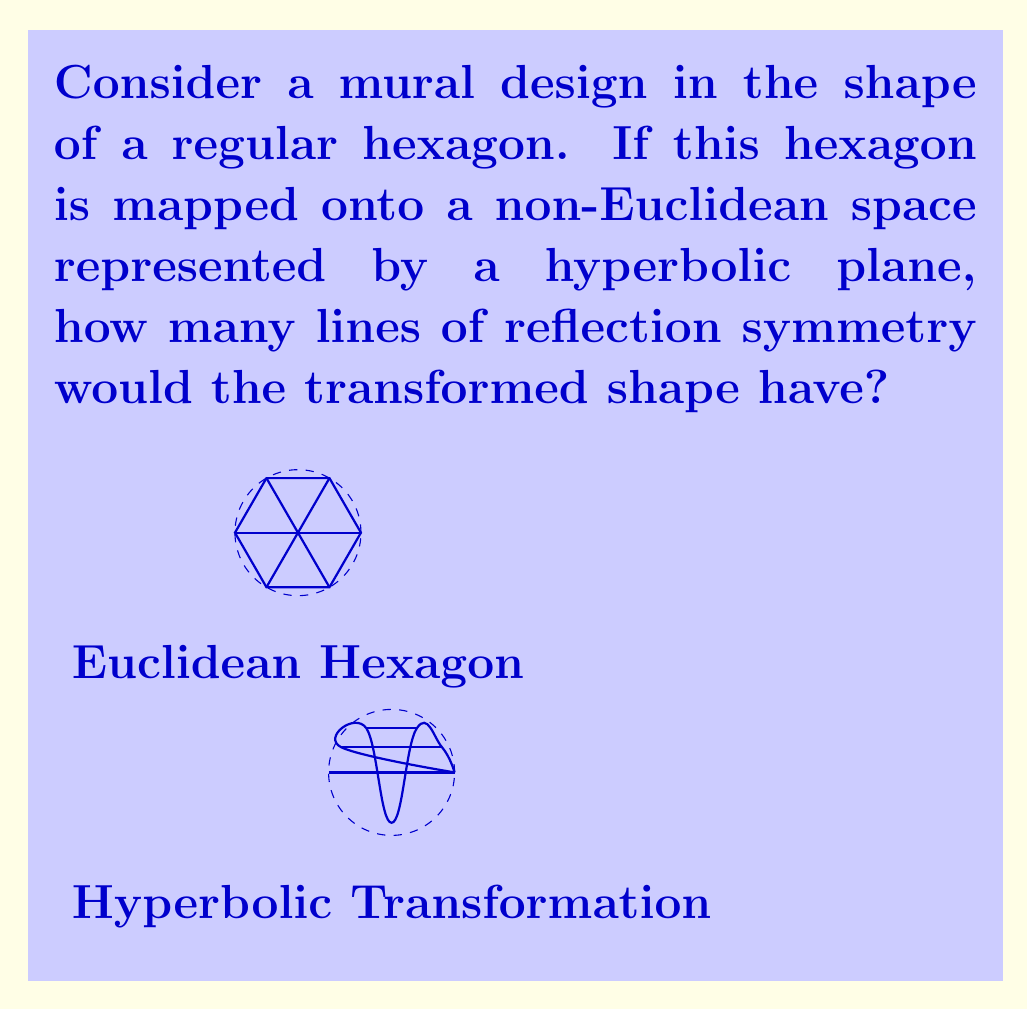Could you help me with this problem? To solve this problem, we need to understand how symmetry properties are preserved or altered when transforming shapes from Euclidean to non-Euclidean spaces:

1) In Euclidean space, a regular hexagon has 6 lines of reflection symmetry: 3 passing through opposite vertices and 3 passing through the midpoints of opposite sides.

2) When mapping to a hyperbolic plane, straight lines in Euclidean space become curved. However, the number of symmetries is generally preserved under continuous transformations.

3) In hyperbolic geometry, lines of reflection symmetry become geodesics (shortest paths between two points in the curved space).

4) The transformation from Euclidean to hyperbolic space is conformal, meaning it preserves angles locally. This property ensures that the symmetry lines will still intersect the hexagon's perimeter at right angles.

5) While the shape of the hexagon will be distorted in the hyperbolic plane (appearing more "puffed out" towards the edges), the number of reflection symmetries remains unchanged.

6) Each of the original 6 lines of symmetry in the Euclidean hexagon will correspond to a geodesic line of symmetry in the hyperbolic plane.

Therefore, the number of lines of reflection symmetry for the hexagon mapped onto the hyperbolic plane remains 6, just as in Euclidean space.
Answer: The transformed shape in the hyperbolic plane would have 6 lines of reflection symmetry. 